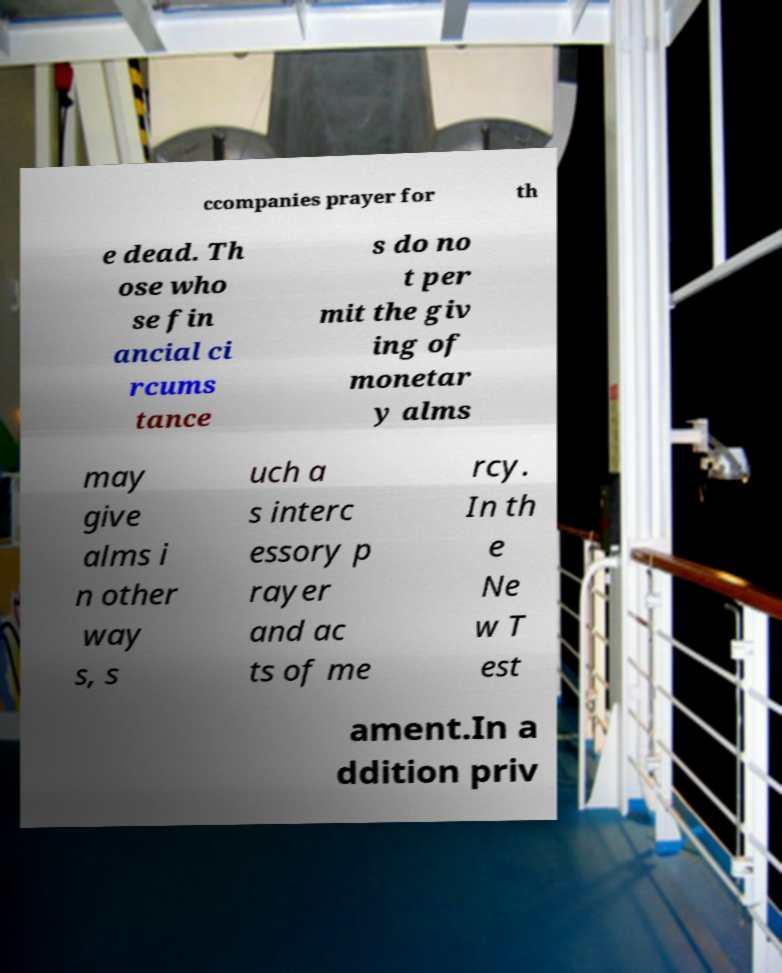There's text embedded in this image that I need extracted. Can you transcribe it verbatim? ccompanies prayer for th e dead. Th ose who se fin ancial ci rcums tance s do no t per mit the giv ing of monetar y alms may give alms i n other way s, s uch a s interc essory p rayer and ac ts of me rcy. In th e Ne w T est ament.In a ddition priv 